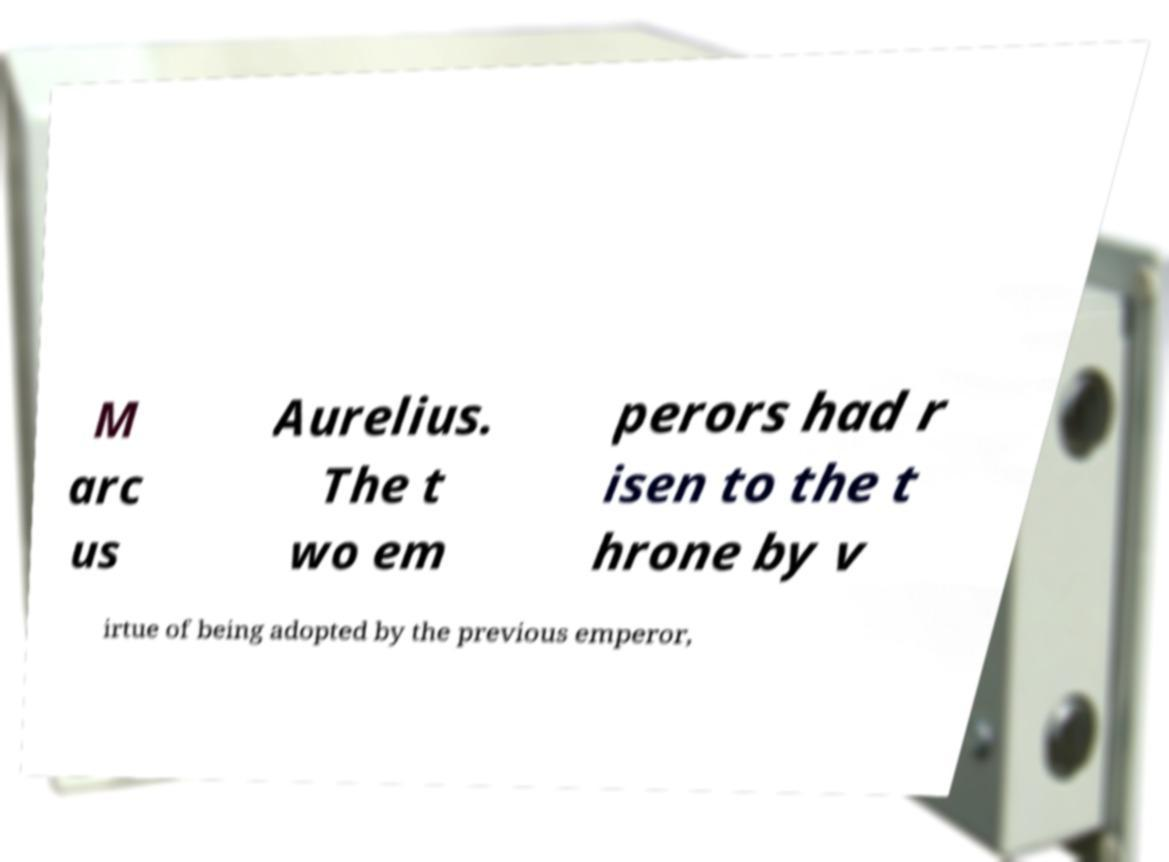I need the written content from this picture converted into text. Can you do that? M arc us Aurelius. The t wo em perors had r isen to the t hrone by v irtue of being adopted by the previous emperor, 